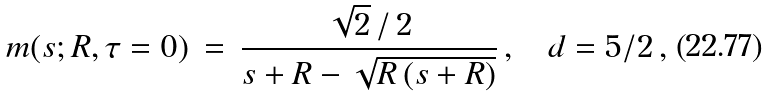<formula> <loc_0><loc_0><loc_500><loc_500>m ( s ; R , \tau = 0 ) \, = \, \frac { \sqrt { 2 } \, / \, 2 } { s + R - \sqrt { R \, ( s + R ) } } \, , \quad d = 5 / 2 \, ,</formula> 